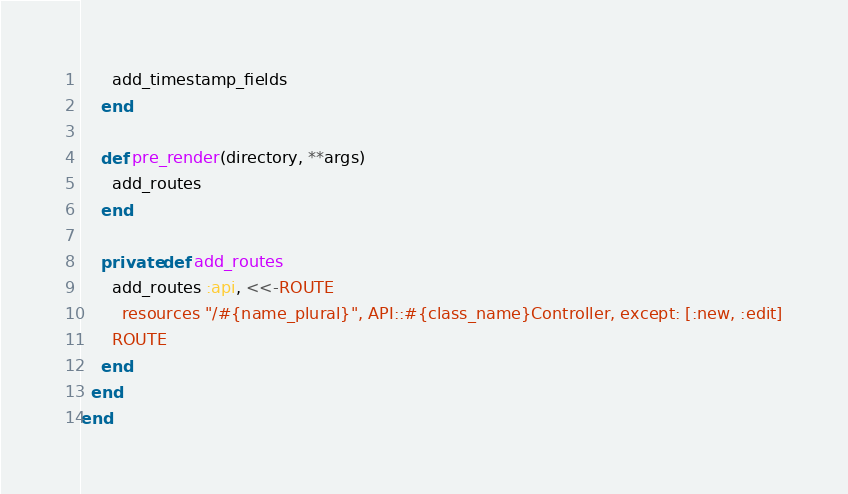Convert code to text. <code><loc_0><loc_0><loc_500><loc_500><_Crystal_>      add_timestamp_fields
    end

    def pre_render(directory, **args)
      add_routes
    end

    private def add_routes
      add_routes :api, <<-ROUTE
        resources "/#{name_plural}", API::#{class_name}Controller, except: [:new, :edit]
      ROUTE
    end
  end
end
</code> 